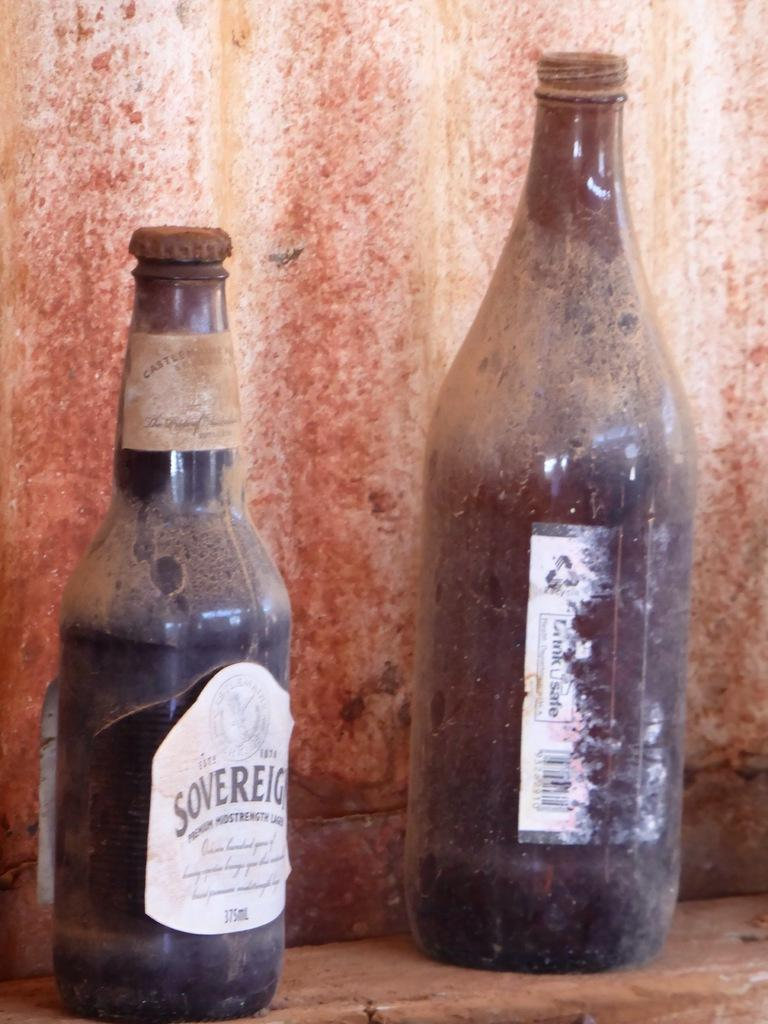<image>
Render a clear and concise summary of the photo. To old rusty and dirty bottles of Lager on a shelf. 